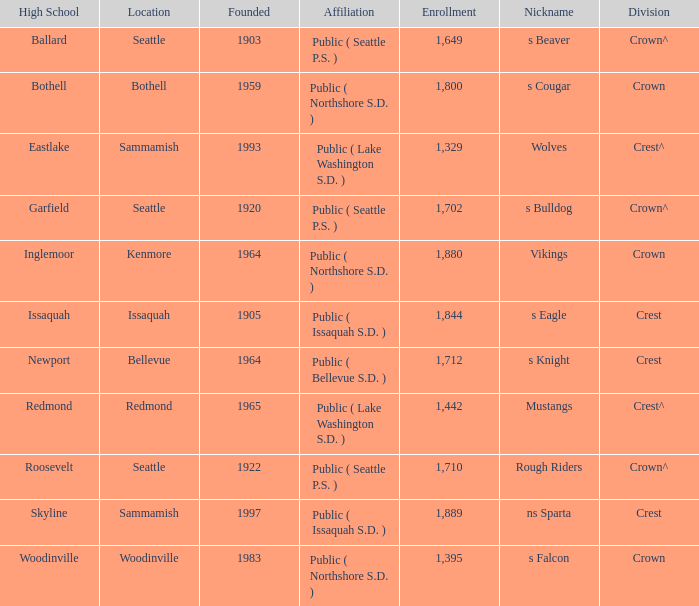Would you be able to parse every entry in this table? {'header': ['High School', 'Location', 'Founded', 'Affiliation', 'Enrollment', 'Nickname', 'Division'], 'rows': [['Ballard', 'Seattle', '1903', 'Public ( Seattle P.S. )', '1,649', 's Beaver', 'Crown^'], ['Bothell', 'Bothell', '1959', 'Public ( Northshore S.D. )', '1,800', 's Cougar', 'Crown'], ['Eastlake', 'Sammamish', '1993', 'Public ( Lake Washington S.D. )', '1,329', 'Wolves', 'Crest^'], ['Garfield', 'Seattle', '1920', 'Public ( Seattle P.S. )', '1,702', 's Bulldog', 'Crown^'], ['Inglemoor', 'Kenmore', '1964', 'Public ( Northshore S.D. )', '1,880', 'Vikings', 'Crown'], ['Issaquah', 'Issaquah', '1905', 'Public ( Issaquah S.D. )', '1,844', 's Eagle', 'Crest'], ['Newport', 'Bellevue', '1964', 'Public ( Bellevue S.D. )', '1,712', 's Knight', 'Crest'], ['Redmond', 'Redmond', '1965', 'Public ( Lake Washington S.D. )', '1,442', 'Mustangs', 'Crest^'], ['Roosevelt', 'Seattle', '1922', 'Public ( Seattle P.S. )', '1,710', 'Rough Riders', 'Crown^'], ['Skyline', 'Sammamish', '1997', 'Public ( Issaquah S.D. )', '1,889', 'ns Sparta', 'Crest'], ['Woodinville', 'Woodinville', '1983', 'Public ( Northshore S.D. )', '1,395', 's Falcon', 'Crown']]} What High School with a nickname of S Eagle has a Division of crest? Issaquah. 